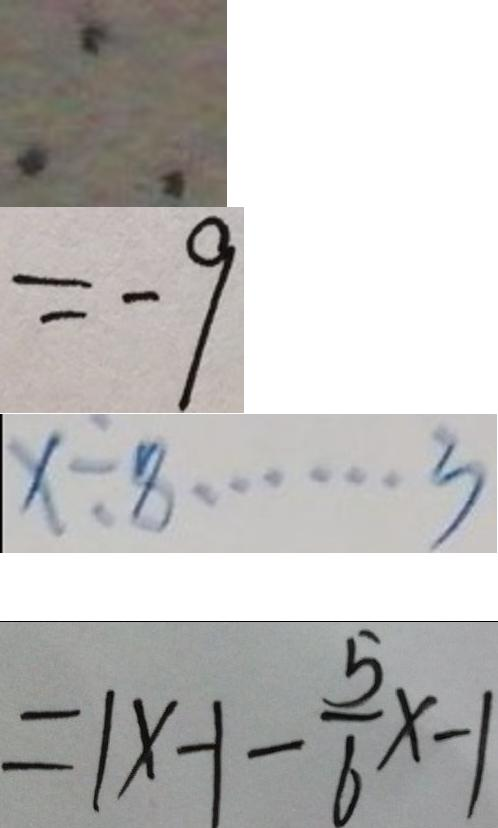Convert formula to latex. <formula><loc_0><loc_0><loc_500><loc_500>\therefore 
 = - 9 
 x \div 8 \cdots 3 
 = 1 x - 1 - \frac { 5 } { 6 } x - 1</formula> 